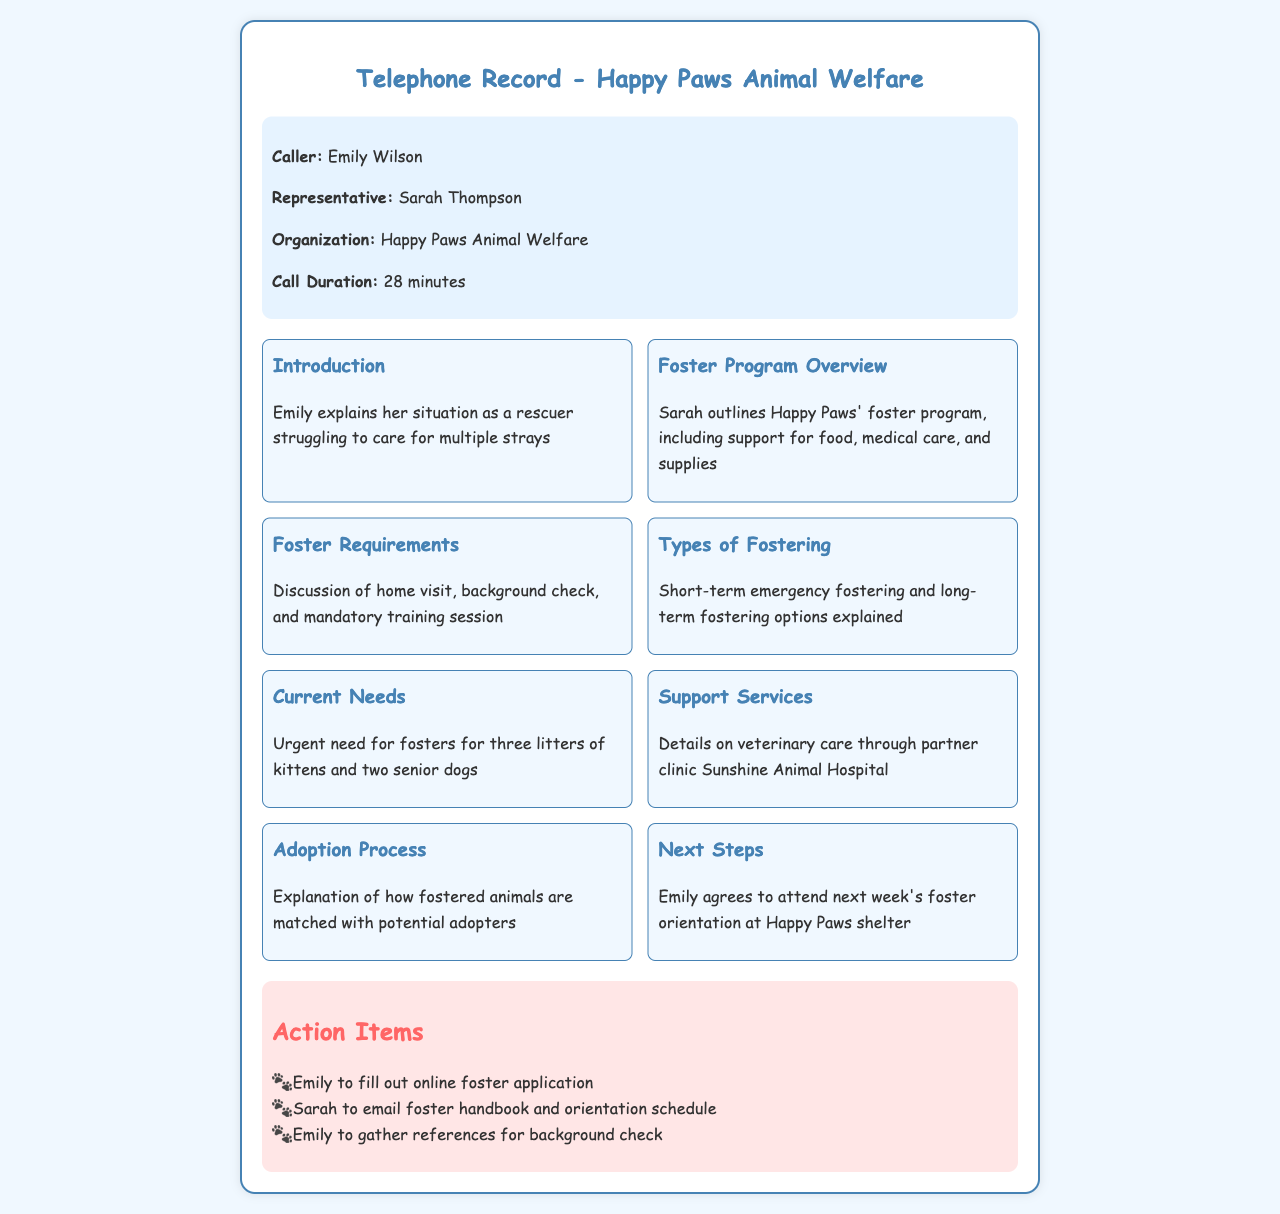What is the name of the caller? The caller's name, as stated in the document, is Emily Wilson.
Answer: Emily Wilson Who is the representative from Happy Paws? The document indicates that the representative is Sarah Thompson.
Answer: Sarah Thompson How long was the call? The call duration is specifically mentioned as 28 minutes in the document.
Answer: 28 minutes What organization is Emily speaking with? The organization that Emily is in contact with is Happy Paws Animal Welfare.
Answer: Happy Paws Animal Welfare What types of fostering are discussed? The document details both short-term emergency fostering and long-term fostering options.
Answer: Short-term emergency fostering and long-term fostering What is the urgent current need stated? According to the document, there is an urgent need for fosters for three litters of kittens and two senior dogs.
Answer: Three litters of kittens and two senior dogs What is the next step Emily has agreed to? Emily has agreed to attend next week's foster orientation at Happy Paws shelter.
Answer: Attend next week's foster orientation What will Sarah email to Emily? Sarah will email the foster handbook and orientation schedule to Emily.
Answer: Foster handbook and orientation schedule What is required before fostering? The document notes that a home visit, background check, and mandatory training session are required before fostering.
Answer: Home visit, background check, and mandatory training session 